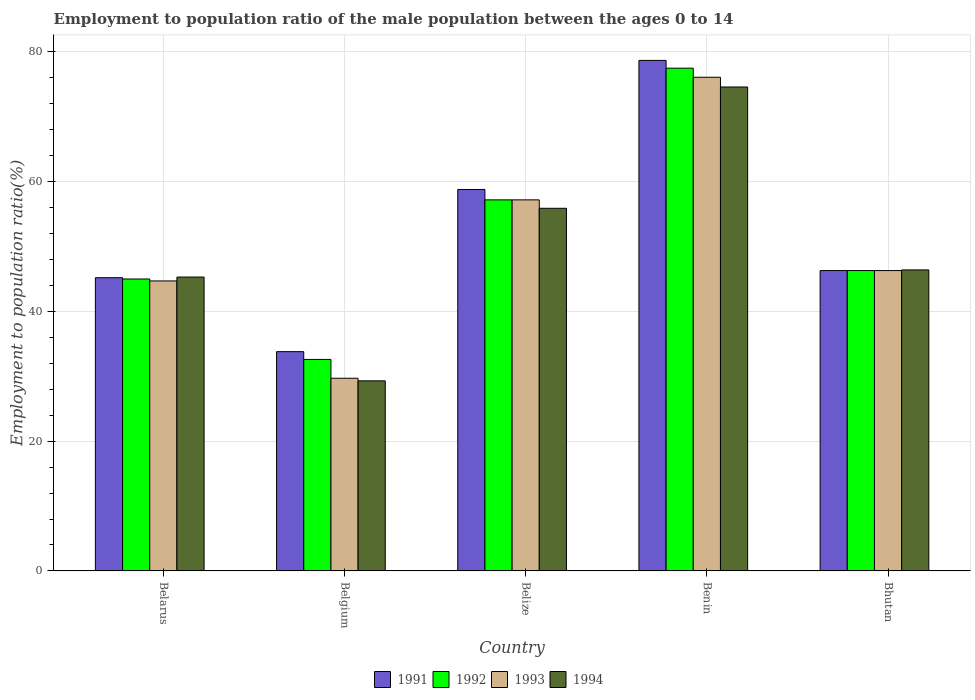How many groups of bars are there?
Your response must be concise. 5. Are the number of bars per tick equal to the number of legend labels?
Offer a very short reply. Yes. How many bars are there on the 2nd tick from the left?
Provide a short and direct response. 4. What is the label of the 4th group of bars from the left?
Ensure brevity in your answer.  Benin. In how many cases, is the number of bars for a given country not equal to the number of legend labels?
Provide a succinct answer. 0. What is the employment to population ratio in 1993 in Belgium?
Provide a short and direct response. 29.7. Across all countries, what is the maximum employment to population ratio in 1991?
Give a very brief answer. 78.7. Across all countries, what is the minimum employment to population ratio in 1993?
Keep it short and to the point. 29.7. In which country was the employment to population ratio in 1992 maximum?
Your answer should be compact. Benin. In which country was the employment to population ratio in 1992 minimum?
Keep it short and to the point. Belgium. What is the total employment to population ratio in 1994 in the graph?
Keep it short and to the point. 251.5. What is the difference between the employment to population ratio in 1993 in Belarus and that in Belgium?
Your answer should be very brief. 15. What is the difference between the employment to population ratio in 1993 in Belarus and the employment to population ratio in 1994 in Belize?
Provide a succinct answer. -11.2. What is the average employment to population ratio in 1993 per country?
Provide a short and direct response. 50.8. What is the difference between the employment to population ratio of/in 1991 and employment to population ratio of/in 1994 in Belarus?
Your answer should be compact. -0.1. In how many countries, is the employment to population ratio in 1993 greater than 52 %?
Give a very brief answer. 2. What is the ratio of the employment to population ratio in 1991 in Belarus to that in Bhutan?
Your answer should be compact. 0.98. What is the difference between the highest and the second highest employment to population ratio in 1993?
Keep it short and to the point. -18.9. What is the difference between the highest and the lowest employment to population ratio in 1994?
Give a very brief answer. 45.3. In how many countries, is the employment to population ratio in 1991 greater than the average employment to population ratio in 1991 taken over all countries?
Your response must be concise. 2. How many bars are there?
Offer a very short reply. 20. Does the graph contain any zero values?
Offer a very short reply. No. Where does the legend appear in the graph?
Your answer should be compact. Bottom center. How many legend labels are there?
Your answer should be compact. 4. How are the legend labels stacked?
Provide a short and direct response. Horizontal. What is the title of the graph?
Make the answer very short. Employment to population ratio of the male population between the ages 0 to 14. What is the label or title of the X-axis?
Provide a succinct answer. Country. What is the label or title of the Y-axis?
Offer a terse response. Employment to population ratio(%). What is the Employment to population ratio(%) in 1991 in Belarus?
Make the answer very short. 45.2. What is the Employment to population ratio(%) in 1992 in Belarus?
Give a very brief answer. 45. What is the Employment to population ratio(%) of 1993 in Belarus?
Provide a succinct answer. 44.7. What is the Employment to population ratio(%) in 1994 in Belarus?
Keep it short and to the point. 45.3. What is the Employment to population ratio(%) in 1991 in Belgium?
Offer a terse response. 33.8. What is the Employment to population ratio(%) in 1992 in Belgium?
Your answer should be compact. 32.6. What is the Employment to population ratio(%) of 1993 in Belgium?
Offer a terse response. 29.7. What is the Employment to population ratio(%) in 1994 in Belgium?
Offer a very short reply. 29.3. What is the Employment to population ratio(%) of 1991 in Belize?
Offer a very short reply. 58.8. What is the Employment to population ratio(%) in 1992 in Belize?
Make the answer very short. 57.2. What is the Employment to population ratio(%) in 1993 in Belize?
Keep it short and to the point. 57.2. What is the Employment to population ratio(%) of 1994 in Belize?
Provide a short and direct response. 55.9. What is the Employment to population ratio(%) of 1991 in Benin?
Offer a terse response. 78.7. What is the Employment to population ratio(%) in 1992 in Benin?
Give a very brief answer. 77.5. What is the Employment to population ratio(%) in 1993 in Benin?
Your answer should be compact. 76.1. What is the Employment to population ratio(%) of 1994 in Benin?
Offer a terse response. 74.6. What is the Employment to population ratio(%) of 1991 in Bhutan?
Your answer should be very brief. 46.3. What is the Employment to population ratio(%) of 1992 in Bhutan?
Offer a very short reply. 46.3. What is the Employment to population ratio(%) of 1993 in Bhutan?
Ensure brevity in your answer.  46.3. What is the Employment to population ratio(%) of 1994 in Bhutan?
Your response must be concise. 46.4. Across all countries, what is the maximum Employment to population ratio(%) of 1991?
Make the answer very short. 78.7. Across all countries, what is the maximum Employment to population ratio(%) of 1992?
Ensure brevity in your answer.  77.5. Across all countries, what is the maximum Employment to population ratio(%) in 1993?
Ensure brevity in your answer.  76.1. Across all countries, what is the maximum Employment to population ratio(%) in 1994?
Keep it short and to the point. 74.6. Across all countries, what is the minimum Employment to population ratio(%) of 1991?
Ensure brevity in your answer.  33.8. Across all countries, what is the minimum Employment to population ratio(%) of 1992?
Your answer should be very brief. 32.6. Across all countries, what is the minimum Employment to population ratio(%) of 1993?
Your answer should be compact. 29.7. Across all countries, what is the minimum Employment to population ratio(%) in 1994?
Offer a terse response. 29.3. What is the total Employment to population ratio(%) in 1991 in the graph?
Ensure brevity in your answer.  262.8. What is the total Employment to population ratio(%) of 1992 in the graph?
Offer a terse response. 258.6. What is the total Employment to population ratio(%) in 1993 in the graph?
Make the answer very short. 254. What is the total Employment to population ratio(%) of 1994 in the graph?
Make the answer very short. 251.5. What is the difference between the Employment to population ratio(%) in 1991 in Belarus and that in Belgium?
Ensure brevity in your answer.  11.4. What is the difference between the Employment to population ratio(%) of 1992 in Belarus and that in Belgium?
Provide a short and direct response. 12.4. What is the difference between the Employment to population ratio(%) of 1994 in Belarus and that in Belgium?
Your answer should be very brief. 16. What is the difference between the Employment to population ratio(%) of 1991 in Belarus and that in Belize?
Provide a short and direct response. -13.6. What is the difference between the Employment to population ratio(%) of 1993 in Belarus and that in Belize?
Keep it short and to the point. -12.5. What is the difference between the Employment to population ratio(%) of 1994 in Belarus and that in Belize?
Offer a very short reply. -10.6. What is the difference between the Employment to population ratio(%) in 1991 in Belarus and that in Benin?
Provide a succinct answer. -33.5. What is the difference between the Employment to population ratio(%) of 1992 in Belarus and that in Benin?
Ensure brevity in your answer.  -32.5. What is the difference between the Employment to population ratio(%) in 1993 in Belarus and that in Benin?
Ensure brevity in your answer.  -31.4. What is the difference between the Employment to population ratio(%) of 1994 in Belarus and that in Benin?
Your response must be concise. -29.3. What is the difference between the Employment to population ratio(%) in 1993 in Belarus and that in Bhutan?
Your answer should be very brief. -1.6. What is the difference between the Employment to population ratio(%) in 1994 in Belarus and that in Bhutan?
Provide a short and direct response. -1.1. What is the difference between the Employment to population ratio(%) in 1992 in Belgium and that in Belize?
Give a very brief answer. -24.6. What is the difference between the Employment to population ratio(%) of 1993 in Belgium and that in Belize?
Provide a short and direct response. -27.5. What is the difference between the Employment to population ratio(%) in 1994 in Belgium and that in Belize?
Your answer should be very brief. -26.6. What is the difference between the Employment to population ratio(%) of 1991 in Belgium and that in Benin?
Give a very brief answer. -44.9. What is the difference between the Employment to population ratio(%) in 1992 in Belgium and that in Benin?
Your answer should be compact. -44.9. What is the difference between the Employment to population ratio(%) in 1993 in Belgium and that in Benin?
Give a very brief answer. -46.4. What is the difference between the Employment to population ratio(%) of 1994 in Belgium and that in Benin?
Your answer should be very brief. -45.3. What is the difference between the Employment to population ratio(%) in 1991 in Belgium and that in Bhutan?
Make the answer very short. -12.5. What is the difference between the Employment to population ratio(%) in 1992 in Belgium and that in Bhutan?
Ensure brevity in your answer.  -13.7. What is the difference between the Employment to population ratio(%) in 1993 in Belgium and that in Bhutan?
Your answer should be very brief. -16.6. What is the difference between the Employment to population ratio(%) of 1994 in Belgium and that in Bhutan?
Keep it short and to the point. -17.1. What is the difference between the Employment to population ratio(%) in 1991 in Belize and that in Benin?
Offer a terse response. -19.9. What is the difference between the Employment to population ratio(%) of 1992 in Belize and that in Benin?
Provide a succinct answer. -20.3. What is the difference between the Employment to population ratio(%) in 1993 in Belize and that in Benin?
Offer a very short reply. -18.9. What is the difference between the Employment to population ratio(%) of 1994 in Belize and that in Benin?
Offer a very short reply. -18.7. What is the difference between the Employment to population ratio(%) in 1992 in Belize and that in Bhutan?
Keep it short and to the point. 10.9. What is the difference between the Employment to population ratio(%) of 1993 in Belize and that in Bhutan?
Provide a short and direct response. 10.9. What is the difference between the Employment to population ratio(%) of 1994 in Belize and that in Bhutan?
Make the answer very short. 9.5. What is the difference between the Employment to population ratio(%) in 1991 in Benin and that in Bhutan?
Your answer should be compact. 32.4. What is the difference between the Employment to population ratio(%) of 1992 in Benin and that in Bhutan?
Offer a terse response. 31.2. What is the difference between the Employment to population ratio(%) in 1993 in Benin and that in Bhutan?
Keep it short and to the point. 29.8. What is the difference between the Employment to population ratio(%) in 1994 in Benin and that in Bhutan?
Offer a very short reply. 28.2. What is the difference between the Employment to population ratio(%) of 1991 in Belarus and the Employment to population ratio(%) of 1992 in Belgium?
Provide a succinct answer. 12.6. What is the difference between the Employment to population ratio(%) in 1991 in Belarus and the Employment to population ratio(%) in 1993 in Belgium?
Give a very brief answer. 15.5. What is the difference between the Employment to population ratio(%) of 1991 in Belarus and the Employment to population ratio(%) of 1994 in Belgium?
Your answer should be very brief. 15.9. What is the difference between the Employment to population ratio(%) of 1992 in Belarus and the Employment to population ratio(%) of 1993 in Belgium?
Your answer should be compact. 15.3. What is the difference between the Employment to population ratio(%) of 1992 in Belarus and the Employment to population ratio(%) of 1994 in Belgium?
Keep it short and to the point. 15.7. What is the difference between the Employment to population ratio(%) in 1991 in Belarus and the Employment to population ratio(%) in 1993 in Belize?
Your answer should be compact. -12. What is the difference between the Employment to population ratio(%) in 1993 in Belarus and the Employment to population ratio(%) in 1994 in Belize?
Make the answer very short. -11.2. What is the difference between the Employment to population ratio(%) of 1991 in Belarus and the Employment to population ratio(%) of 1992 in Benin?
Your answer should be compact. -32.3. What is the difference between the Employment to population ratio(%) in 1991 in Belarus and the Employment to population ratio(%) in 1993 in Benin?
Your answer should be compact. -30.9. What is the difference between the Employment to population ratio(%) of 1991 in Belarus and the Employment to population ratio(%) of 1994 in Benin?
Your answer should be very brief. -29.4. What is the difference between the Employment to population ratio(%) in 1992 in Belarus and the Employment to population ratio(%) in 1993 in Benin?
Offer a very short reply. -31.1. What is the difference between the Employment to population ratio(%) in 1992 in Belarus and the Employment to population ratio(%) in 1994 in Benin?
Make the answer very short. -29.6. What is the difference between the Employment to population ratio(%) of 1993 in Belarus and the Employment to population ratio(%) of 1994 in Benin?
Provide a succinct answer. -29.9. What is the difference between the Employment to population ratio(%) of 1991 in Belarus and the Employment to population ratio(%) of 1992 in Bhutan?
Offer a terse response. -1.1. What is the difference between the Employment to population ratio(%) of 1992 in Belarus and the Employment to population ratio(%) of 1993 in Bhutan?
Make the answer very short. -1.3. What is the difference between the Employment to population ratio(%) in 1993 in Belarus and the Employment to population ratio(%) in 1994 in Bhutan?
Ensure brevity in your answer.  -1.7. What is the difference between the Employment to population ratio(%) of 1991 in Belgium and the Employment to population ratio(%) of 1992 in Belize?
Your answer should be very brief. -23.4. What is the difference between the Employment to population ratio(%) in 1991 in Belgium and the Employment to population ratio(%) in 1993 in Belize?
Your answer should be very brief. -23.4. What is the difference between the Employment to population ratio(%) of 1991 in Belgium and the Employment to population ratio(%) of 1994 in Belize?
Ensure brevity in your answer.  -22.1. What is the difference between the Employment to population ratio(%) in 1992 in Belgium and the Employment to population ratio(%) in 1993 in Belize?
Ensure brevity in your answer.  -24.6. What is the difference between the Employment to population ratio(%) of 1992 in Belgium and the Employment to population ratio(%) of 1994 in Belize?
Provide a short and direct response. -23.3. What is the difference between the Employment to population ratio(%) in 1993 in Belgium and the Employment to population ratio(%) in 1994 in Belize?
Your response must be concise. -26.2. What is the difference between the Employment to population ratio(%) of 1991 in Belgium and the Employment to population ratio(%) of 1992 in Benin?
Keep it short and to the point. -43.7. What is the difference between the Employment to population ratio(%) of 1991 in Belgium and the Employment to population ratio(%) of 1993 in Benin?
Provide a succinct answer. -42.3. What is the difference between the Employment to population ratio(%) in 1991 in Belgium and the Employment to population ratio(%) in 1994 in Benin?
Your answer should be very brief. -40.8. What is the difference between the Employment to population ratio(%) in 1992 in Belgium and the Employment to population ratio(%) in 1993 in Benin?
Your answer should be very brief. -43.5. What is the difference between the Employment to population ratio(%) of 1992 in Belgium and the Employment to population ratio(%) of 1994 in Benin?
Your answer should be compact. -42. What is the difference between the Employment to population ratio(%) of 1993 in Belgium and the Employment to population ratio(%) of 1994 in Benin?
Your response must be concise. -44.9. What is the difference between the Employment to population ratio(%) in 1991 in Belgium and the Employment to population ratio(%) in 1992 in Bhutan?
Your answer should be very brief. -12.5. What is the difference between the Employment to population ratio(%) of 1991 in Belgium and the Employment to population ratio(%) of 1993 in Bhutan?
Provide a succinct answer. -12.5. What is the difference between the Employment to population ratio(%) in 1991 in Belgium and the Employment to population ratio(%) in 1994 in Bhutan?
Provide a succinct answer. -12.6. What is the difference between the Employment to population ratio(%) of 1992 in Belgium and the Employment to population ratio(%) of 1993 in Bhutan?
Provide a short and direct response. -13.7. What is the difference between the Employment to population ratio(%) in 1993 in Belgium and the Employment to population ratio(%) in 1994 in Bhutan?
Make the answer very short. -16.7. What is the difference between the Employment to population ratio(%) in 1991 in Belize and the Employment to population ratio(%) in 1992 in Benin?
Keep it short and to the point. -18.7. What is the difference between the Employment to population ratio(%) in 1991 in Belize and the Employment to population ratio(%) in 1993 in Benin?
Your answer should be compact. -17.3. What is the difference between the Employment to population ratio(%) of 1991 in Belize and the Employment to population ratio(%) of 1994 in Benin?
Make the answer very short. -15.8. What is the difference between the Employment to population ratio(%) in 1992 in Belize and the Employment to population ratio(%) in 1993 in Benin?
Give a very brief answer. -18.9. What is the difference between the Employment to population ratio(%) in 1992 in Belize and the Employment to population ratio(%) in 1994 in Benin?
Your answer should be compact. -17.4. What is the difference between the Employment to population ratio(%) of 1993 in Belize and the Employment to population ratio(%) of 1994 in Benin?
Your response must be concise. -17.4. What is the difference between the Employment to population ratio(%) of 1991 in Belize and the Employment to population ratio(%) of 1992 in Bhutan?
Give a very brief answer. 12.5. What is the difference between the Employment to population ratio(%) of 1991 in Belize and the Employment to population ratio(%) of 1993 in Bhutan?
Your answer should be compact. 12.5. What is the difference between the Employment to population ratio(%) of 1991 in Belize and the Employment to population ratio(%) of 1994 in Bhutan?
Your response must be concise. 12.4. What is the difference between the Employment to population ratio(%) in 1991 in Benin and the Employment to population ratio(%) in 1992 in Bhutan?
Ensure brevity in your answer.  32.4. What is the difference between the Employment to population ratio(%) of 1991 in Benin and the Employment to population ratio(%) of 1993 in Bhutan?
Make the answer very short. 32.4. What is the difference between the Employment to population ratio(%) in 1991 in Benin and the Employment to population ratio(%) in 1994 in Bhutan?
Your answer should be compact. 32.3. What is the difference between the Employment to population ratio(%) in 1992 in Benin and the Employment to population ratio(%) in 1993 in Bhutan?
Offer a very short reply. 31.2. What is the difference between the Employment to population ratio(%) of 1992 in Benin and the Employment to population ratio(%) of 1994 in Bhutan?
Offer a very short reply. 31.1. What is the difference between the Employment to population ratio(%) of 1993 in Benin and the Employment to population ratio(%) of 1994 in Bhutan?
Your response must be concise. 29.7. What is the average Employment to population ratio(%) in 1991 per country?
Your response must be concise. 52.56. What is the average Employment to population ratio(%) in 1992 per country?
Give a very brief answer. 51.72. What is the average Employment to population ratio(%) in 1993 per country?
Your response must be concise. 50.8. What is the average Employment to population ratio(%) in 1994 per country?
Your response must be concise. 50.3. What is the difference between the Employment to population ratio(%) in 1992 and Employment to population ratio(%) in 1994 in Belarus?
Keep it short and to the point. -0.3. What is the difference between the Employment to population ratio(%) of 1991 and Employment to population ratio(%) of 1994 in Belgium?
Provide a succinct answer. 4.5. What is the difference between the Employment to population ratio(%) in 1992 and Employment to population ratio(%) in 1994 in Belgium?
Give a very brief answer. 3.3. What is the difference between the Employment to population ratio(%) in 1991 and Employment to population ratio(%) in 1992 in Belize?
Ensure brevity in your answer.  1.6. What is the difference between the Employment to population ratio(%) of 1991 and Employment to population ratio(%) of 1994 in Belize?
Make the answer very short. 2.9. What is the difference between the Employment to population ratio(%) in 1992 and Employment to population ratio(%) in 1994 in Belize?
Ensure brevity in your answer.  1.3. What is the difference between the Employment to population ratio(%) in 1993 and Employment to population ratio(%) in 1994 in Belize?
Your response must be concise. 1.3. What is the difference between the Employment to population ratio(%) in 1991 and Employment to population ratio(%) in 1992 in Benin?
Your answer should be very brief. 1.2. What is the difference between the Employment to population ratio(%) of 1991 and Employment to population ratio(%) of 1993 in Benin?
Make the answer very short. 2.6. What is the difference between the Employment to population ratio(%) of 1992 and Employment to population ratio(%) of 1993 in Benin?
Provide a succinct answer. 1.4. What is the difference between the Employment to population ratio(%) of 1991 and Employment to population ratio(%) of 1992 in Bhutan?
Provide a succinct answer. 0. What is the difference between the Employment to population ratio(%) of 1991 and Employment to population ratio(%) of 1993 in Bhutan?
Your answer should be compact. 0. What is the difference between the Employment to population ratio(%) of 1991 and Employment to population ratio(%) of 1994 in Bhutan?
Your answer should be very brief. -0.1. What is the difference between the Employment to population ratio(%) in 1992 and Employment to population ratio(%) in 1994 in Bhutan?
Make the answer very short. -0.1. What is the difference between the Employment to population ratio(%) in 1993 and Employment to population ratio(%) in 1994 in Bhutan?
Your response must be concise. -0.1. What is the ratio of the Employment to population ratio(%) in 1991 in Belarus to that in Belgium?
Keep it short and to the point. 1.34. What is the ratio of the Employment to population ratio(%) in 1992 in Belarus to that in Belgium?
Keep it short and to the point. 1.38. What is the ratio of the Employment to population ratio(%) of 1993 in Belarus to that in Belgium?
Offer a very short reply. 1.51. What is the ratio of the Employment to population ratio(%) of 1994 in Belarus to that in Belgium?
Give a very brief answer. 1.55. What is the ratio of the Employment to population ratio(%) in 1991 in Belarus to that in Belize?
Your response must be concise. 0.77. What is the ratio of the Employment to population ratio(%) of 1992 in Belarus to that in Belize?
Make the answer very short. 0.79. What is the ratio of the Employment to population ratio(%) of 1993 in Belarus to that in Belize?
Provide a succinct answer. 0.78. What is the ratio of the Employment to population ratio(%) in 1994 in Belarus to that in Belize?
Your answer should be compact. 0.81. What is the ratio of the Employment to population ratio(%) in 1991 in Belarus to that in Benin?
Your answer should be very brief. 0.57. What is the ratio of the Employment to population ratio(%) of 1992 in Belarus to that in Benin?
Give a very brief answer. 0.58. What is the ratio of the Employment to population ratio(%) of 1993 in Belarus to that in Benin?
Your answer should be compact. 0.59. What is the ratio of the Employment to population ratio(%) in 1994 in Belarus to that in Benin?
Your response must be concise. 0.61. What is the ratio of the Employment to population ratio(%) in 1991 in Belarus to that in Bhutan?
Offer a terse response. 0.98. What is the ratio of the Employment to population ratio(%) in 1992 in Belarus to that in Bhutan?
Offer a very short reply. 0.97. What is the ratio of the Employment to population ratio(%) of 1993 in Belarus to that in Bhutan?
Give a very brief answer. 0.97. What is the ratio of the Employment to population ratio(%) of 1994 in Belarus to that in Bhutan?
Give a very brief answer. 0.98. What is the ratio of the Employment to population ratio(%) in 1991 in Belgium to that in Belize?
Make the answer very short. 0.57. What is the ratio of the Employment to population ratio(%) in 1992 in Belgium to that in Belize?
Your answer should be very brief. 0.57. What is the ratio of the Employment to population ratio(%) in 1993 in Belgium to that in Belize?
Provide a short and direct response. 0.52. What is the ratio of the Employment to population ratio(%) of 1994 in Belgium to that in Belize?
Make the answer very short. 0.52. What is the ratio of the Employment to population ratio(%) of 1991 in Belgium to that in Benin?
Offer a very short reply. 0.43. What is the ratio of the Employment to population ratio(%) in 1992 in Belgium to that in Benin?
Provide a succinct answer. 0.42. What is the ratio of the Employment to population ratio(%) in 1993 in Belgium to that in Benin?
Keep it short and to the point. 0.39. What is the ratio of the Employment to population ratio(%) of 1994 in Belgium to that in Benin?
Give a very brief answer. 0.39. What is the ratio of the Employment to population ratio(%) of 1991 in Belgium to that in Bhutan?
Ensure brevity in your answer.  0.73. What is the ratio of the Employment to population ratio(%) of 1992 in Belgium to that in Bhutan?
Give a very brief answer. 0.7. What is the ratio of the Employment to population ratio(%) of 1993 in Belgium to that in Bhutan?
Make the answer very short. 0.64. What is the ratio of the Employment to population ratio(%) of 1994 in Belgium to that in Bhutan?
Provide a succinct answer. 0.63. What is the ratio of the Employment to population ratio(%) of 1991 in Belize to that in Benin?
Your response must be concise. 0.75. What is the ratio of the Employment to population ratio(%) of 1992 in Belize to that in Benin?
Your answer should be compact. 0.74. What is the ratio of the Employment to population ratio(%) of 1993 in Belize to that in Benin?
Offer a very short reply. 0.75. What is the ratio of the Employment to population ratio(%) in 1994 in Belize to that in Benin?
Keep it short and to the point. 0.75. What is the ratio of the Employment to population ratio(%) in 1991 in Belize to that in Bhutan?
Make the answer very short. 1.27. What is the ratio of the Employment to population ratio(%) of 1992 in Belize to that in Bhutan?
Keep it short and to the point. 1.24. What is the ratio of the Employment to population ratio(%) in 1993 in Belize to that in Bhutan?
Your response must be concise. 1.24. What is the ratio of the Employment to population ratio(%) of 1994 in Belize to that in Bhutan?
Your answer should be compact. 1.2. What is the ratio of the Employment to population ratio(%) in 1991 in Benin to that in Bhutan?
Make the answer very short. 1.7. What is the ratio of the Employment to population ratio(%) in 1992 in Benin to that in Bhutan?
Make the answer very short. 1.67. What is the ratio of the Employment to population ratio(%) in 1993 in Benin to that in Bhutan?
Provide a succinct answer. 1.64. What is the ratio of the Employment to population ratio(%) in 1994 in Benin to that in Bhutan?
Offer a terse response. 1.61. What is the difference between the highest and the second highest Employment to population ratio(%) of 1991?
Offer a very short reply. 19.9. What is the difference between the highest and the second highest Employment to population ratio(%) of 1992?
Keep it short and to the point. 20.3. What is the difference between the highest and the second highest Employment to population ratio(%) in 1993?
Offer a very short reply. 18.9. What is the difference between the highest and the lowest Employment to population ratio(%) of 1991?
Make the answer very short. 44.9. What is the difference between the highest and the lowest Employment to population ratio(%) of 1992?
Offer a very short reply. 44.9. What is the difference between the highest and the lowest Employment to population ratio(%) of 1993?
Offer a terse response. 46.4. What is the difference between the highest and the lowest Employment to population ratio(%) of 1994?
Keep it short and to the point. 45.3. 